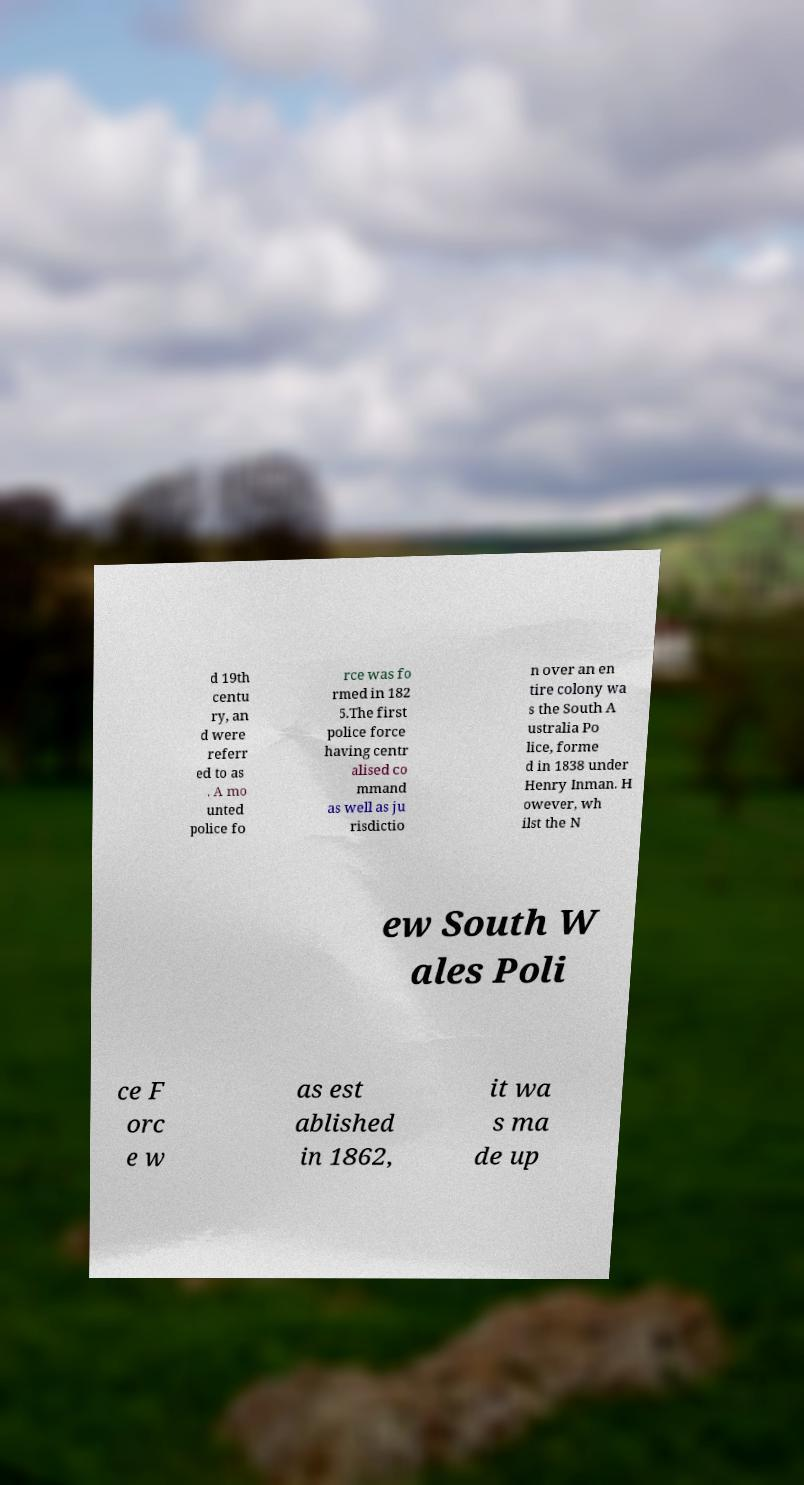Please identify and transcribe the text found in this image. d 19th centu ry, an d were referr ed to as . A mo unted police fo rce was fo rmed in 182 5.The first police force having centr alised co mmand as well as ju risdictio n over an en tire colony wa s the South A ustralia Po lice, forme d in 1838 under Henry Inman. H owever, wh ilst the N ew South W ales Poli ce F orc e w as est ablished in 1862, it wa s ma de up 